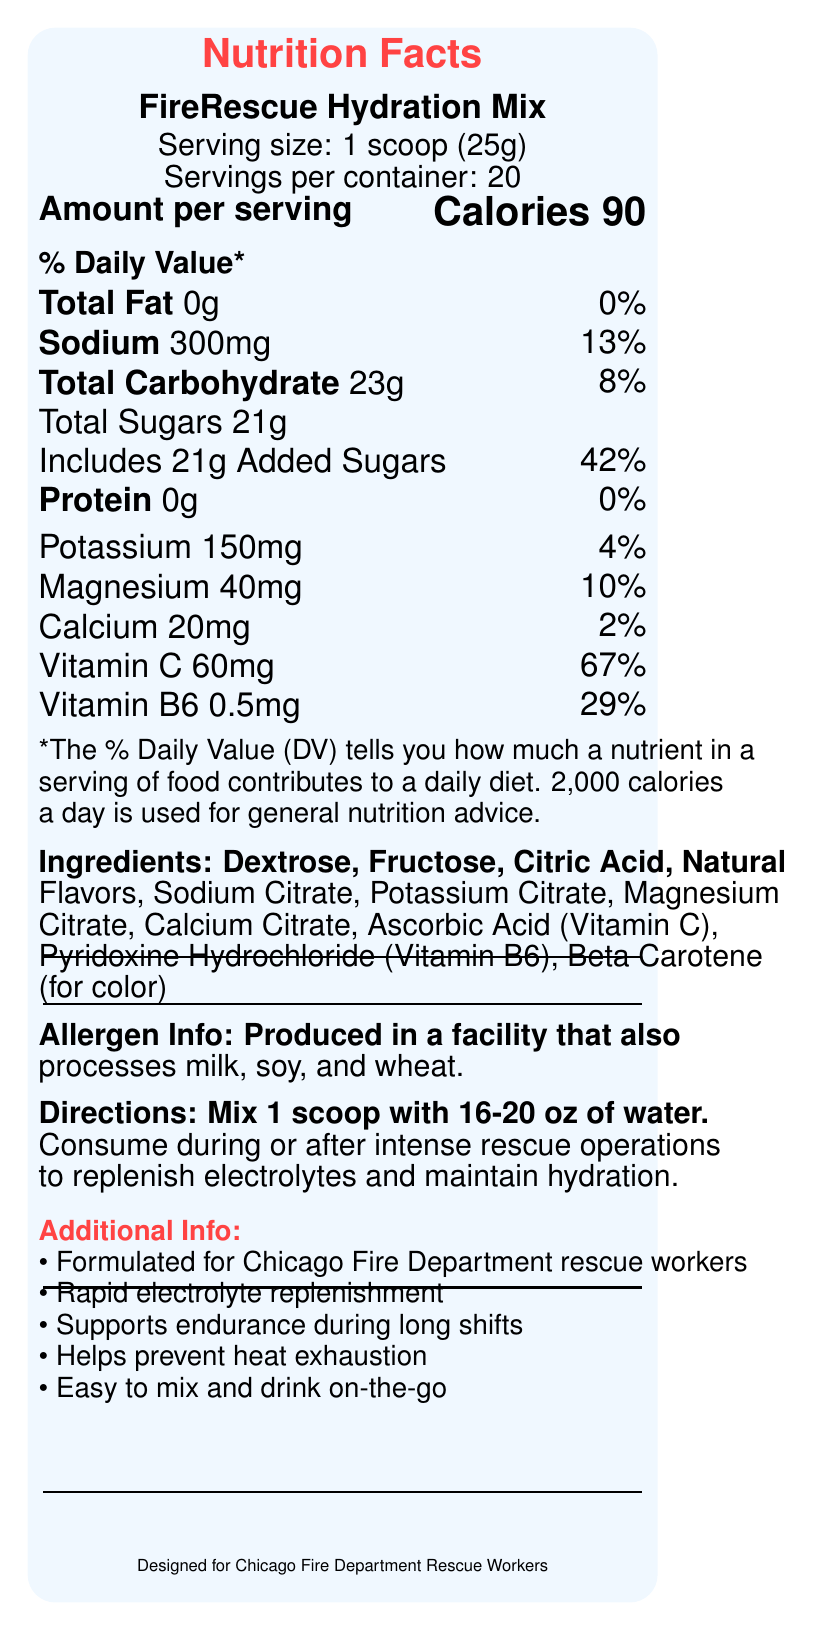what is the serving size? The serving size information is clearly listed as 1 scoop (25g) on the label.
Answer: 1 scoop (25g) how many servings per container are there? The label states that there are 20 servings per container.
Answer: 20 how many calories are in one serving? The calorie count per serving is shown as 90 on the label.
Answer: 90 how much sodium is in one serving? The sodium content per serving is provided as 300mg.
Answer: 300mg what percentage of daily value is contributed by total sugars? The label shows that total sugars contribute 42% to the daily value.
Answer: 42% how much vitamin C is in one serving? The label indicates that one serving contains 60mg of Vitamin C.
Answer: 60mg what are the main electrolytes included in the mix? A. Sodium, Potassium, Magnesium B. Sodium, Calcium, Vitamin C C. Potassium, Magnesium, Vitamin B6 D. Sodium, Magnesium, Vitamin B6 The primary electrolytes listed in the ingredients and nutrition facts are Sodium, Potassium, and Magnesium.
Answer: A. Sodium, Potassium, Magnesium how many ingredients are listed on the label? A. 9 B. 10 C. 11 D. 12 Counting all the ingredients listed, there are 11 in total.
Answer: C. 11 is the product safe for someone with a milk allergy? The allergen info states that the product is produced in a facility that also processes milk, soy, and wheat, which may pose a risk to someone with a milk allergy.
Answer: No does one serving contain any protein? The label indicates that one serving contains 0g of protein, which is 0% of the daily value.
Answer: No what is the primary purpose of the FireRescue Hydration Mix? The label mentions its purpose clearly: to replenish electrolytes and maintain hydration during intense rescue operations.
Answer: Replenishing electrolytes lost during intense rescue operations and maintaining hydration how should the FireRescue Hydration Mix be consumed? The directions for use specify mixing 1 scoop with 16-20 oz of water and consuming it during or after intense rescue operations.
Answer: Mix 1 scoop with 16-20 oz of water, consume during or after intense rescue operations how much potassium is in one serving? The label states that there is 150mg of potassium in one serving.
Answer: 150mg does the mix contain any added sugars? The label specifies that there are 21g of added sugars in each serving.
Answer: Yes is this product specifically formulated for a particular group? The additional info section mentions that the product is formulated for Chicago Fire Department rescue workers.
Answer: Yes, Chicago Fire Department rescue workers summarize the nutrition label for the FireRescue Hydration Mix. The summary covers the key nutritional facts, purpose, ingredients, allergens, and directions for using the product as outlined on the label.
Answer: The FireRescue Hydration Mix is designed to replenish electrolytes lost during intense rescue operations for the Chicago Fire Department. Each serving size is 1 scoop (25g) and provides 90 calories, 300mg sodium, 23g carbohydrates (21g sugars), 150mg potassium, 40mg magnesium, 20mg calcium, 60mg Vitamin C, and 0.5mg Vitamin B6. It contains no fat or protein. The mix has ingredients like dextrose, fructose, and several citrates for different minerals, and is produced in a facility processing milk, soy, and wheat. It is intended for rapid electrolyte replenishment and supports endurance during long shifts. what benefits does the product claim to offer? The additional info lists these benefits directly.
Answer: Rapid electrolyte replenishment, supports endurance during long shifts, helps prevent heat exhaustion, easy to mix and drink on-the-go does one serving contain any fat? The label states that one serving contains 0g of total fat.
Answer: No which vitamins are included in the mix? The nutrition facts show that Vitamin C and Vitamin B6 are included in the mix.
Answer: Vitamin C and Vitamin B6 what are the colors used in the product label design? Inspection of the document reveals the use of specific colors: firered and waterbg.
Answer: Red (firered) and waterbg (light blue) what is the manufacturing facility processing data? The exact details about the manufacturing facility processes other than allergen information are not included in the label.
Answer: Cannot be determined 